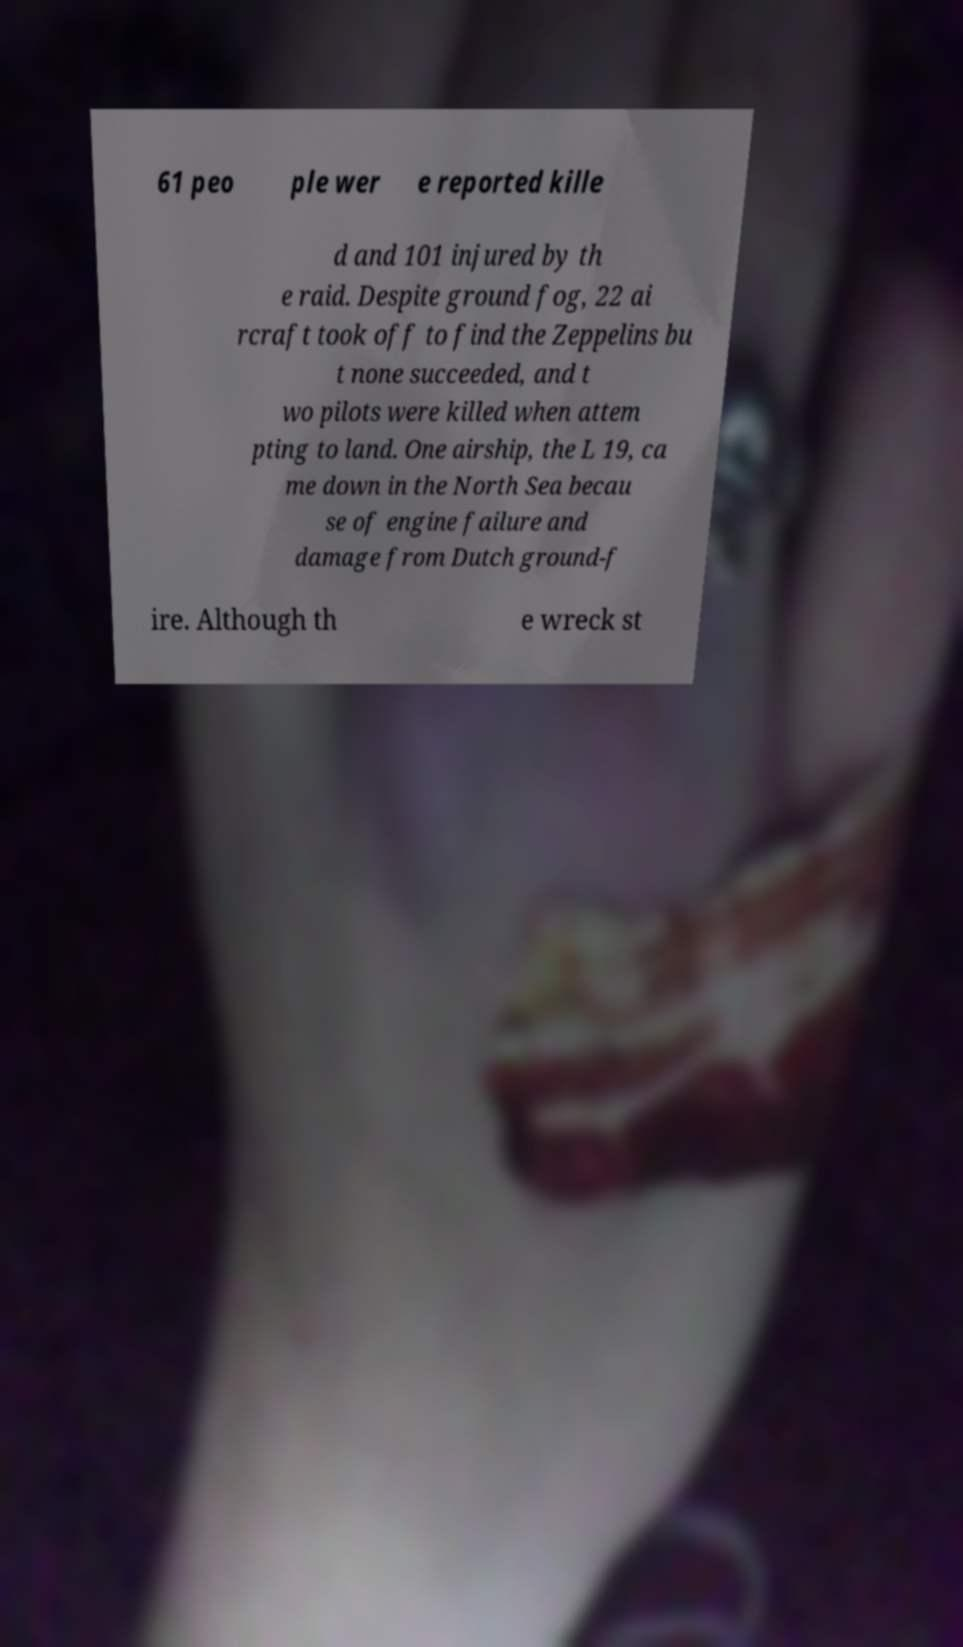Can you read and provide the text displayed in the image?This photo seems to have some interesting text. Can you extract and type it out for me? 61 peo ple wer e reported kille d and 101 injured by th e raid. Despite ground fog, 22 ai rcraft took off to find the Zeppelins bu t none succeeded, and t wo pilots were killed when attem pting to land. One airship, the L 19, ca me down in the North Sea becau se of engine failure and damage from Dutch ground-f ire. Although th e wreck st 